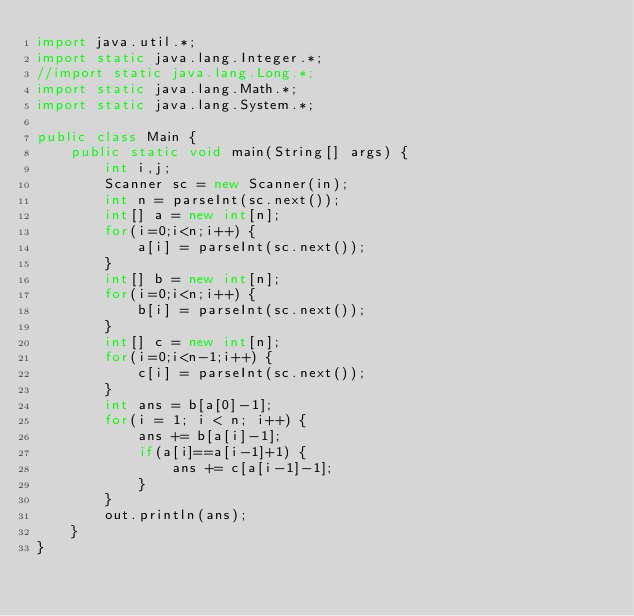Convert code to text. <code><loc_0><loc_0><loc_500><loc_500><_Java_>import java.util.*;
import static java.lang.Integer.*;
//import static java.lang.Long.*;
import static java.lang.Math.*;
import static java.lang.System.*;

public class Main {
	public static void main(String[] args) {
		int i,j;
		Scanner sc = new Scanner(in);
		int n = parseInt(sc.next());
		int[] a = new int[n];
		for(i=0;i<n;i++) {
			a[i] = parseInt(sc.next());
		}
		int[] b = new int[n];
		for(i=0;i<n;i++) {
			b[i] = parseInt(sc.next());
		}
		int[] c = new int[n];
		for(i=0;i<n-1;i++) {
			c[i] = parseInt(sc.next());
		}
		int ans = b[a[0]-1];
		for(i = 1; i < n; i++) {
			ans += b[a[i]-1];
			if(a[i]==a[i-1]+1) {
				ans += c[a[i-1]-1];
			}
		}
		out.println(ans);
	}
}
</code> 